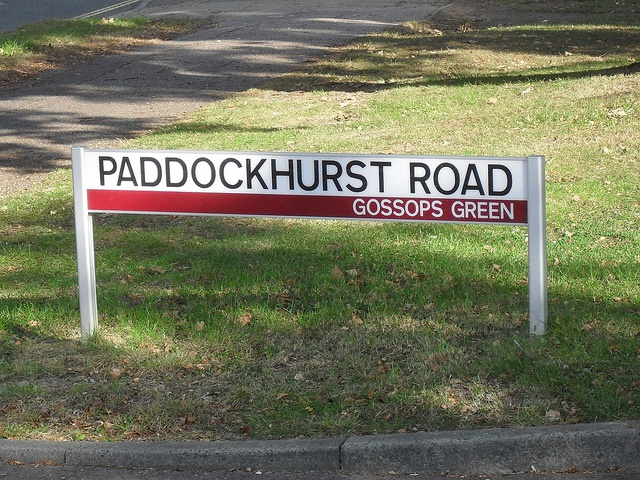Describe the objects in this image and their specific colors. I can see various objects in this image with different colors. 